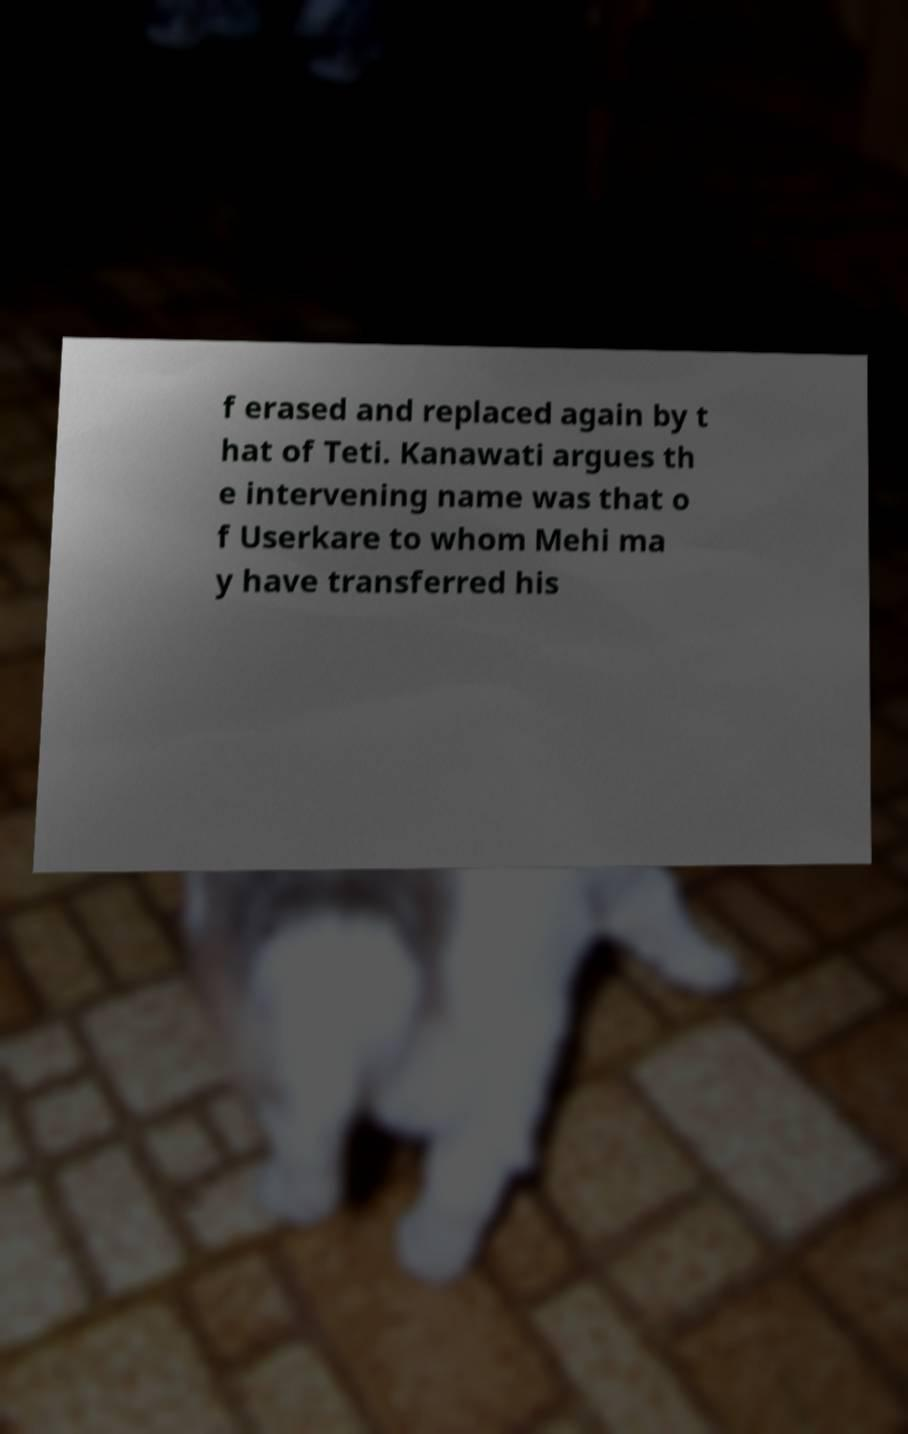I need the written content from this picture converted into text. Can you do that? f erased and replaced again by t hat of Teti. Kanawati argues th e intervening name was that o f Userkare to whom Mehi ma y have transferred his 